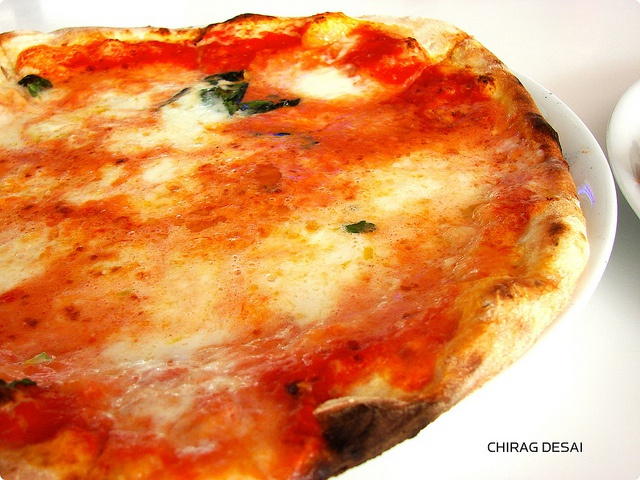Describe the objects in this image and their specific colors. I can see a pizza in red, white, and orange tones in this image. 